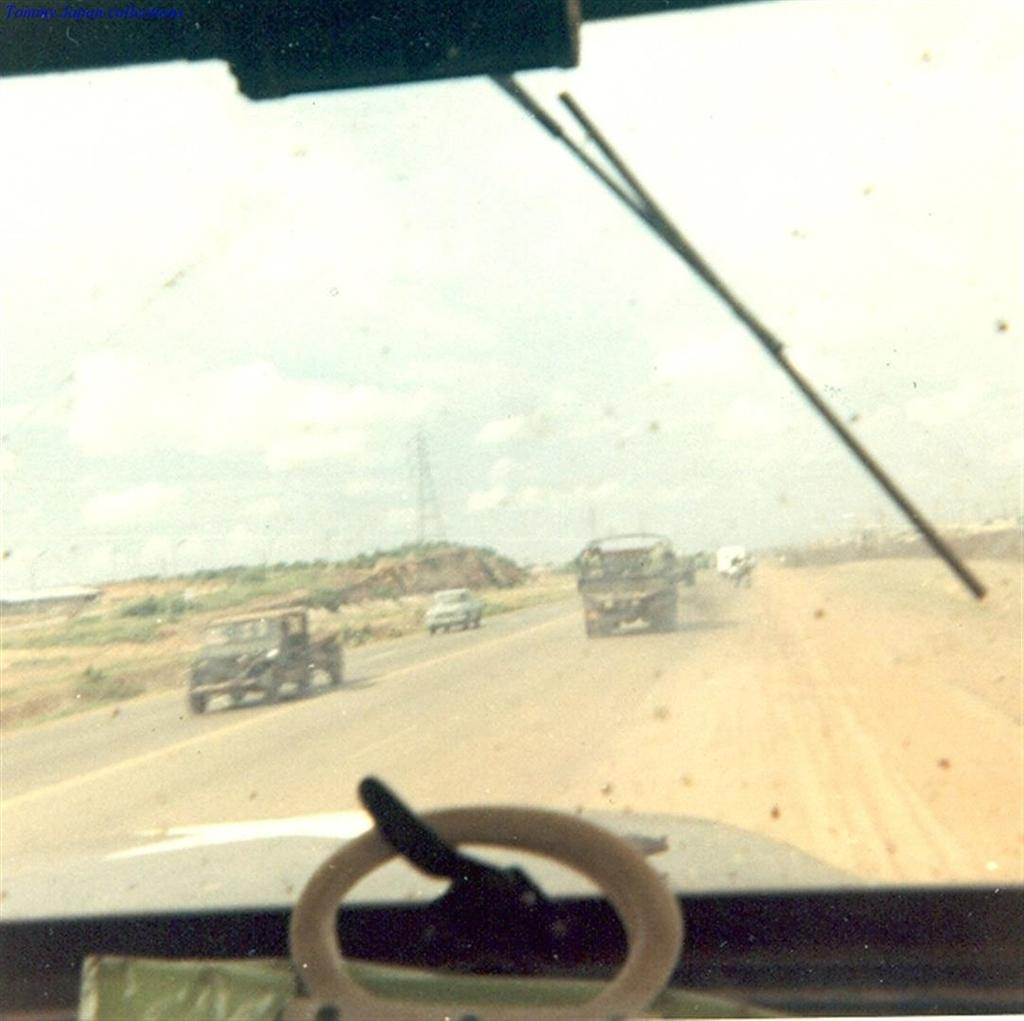What is happening on the road in the image? There are vehicles moving on the road in the image. What structure can be seen in the image? There is a tower visible in the image. What part of the natural environment is visible in the image? The sky is visible in the image. What type of paper can be seen blowing in the field in the image? There is no field or paper present in the image; it features vehicles moving on the road and a tower. What kind of quartz is visible in the image? There is no quartz present in the image. 